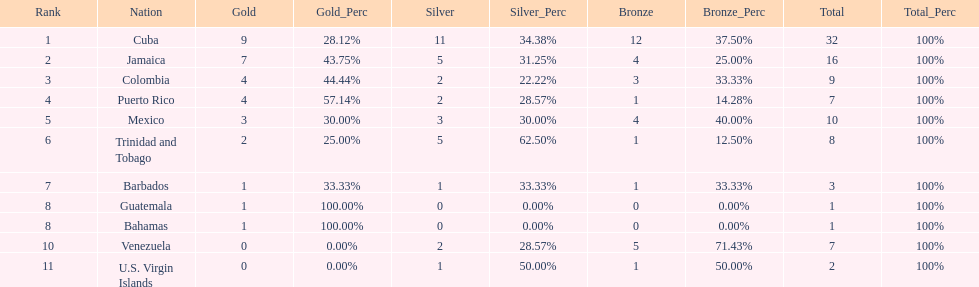What is the total number of gold medals awarded between these 11 countries? 32. 